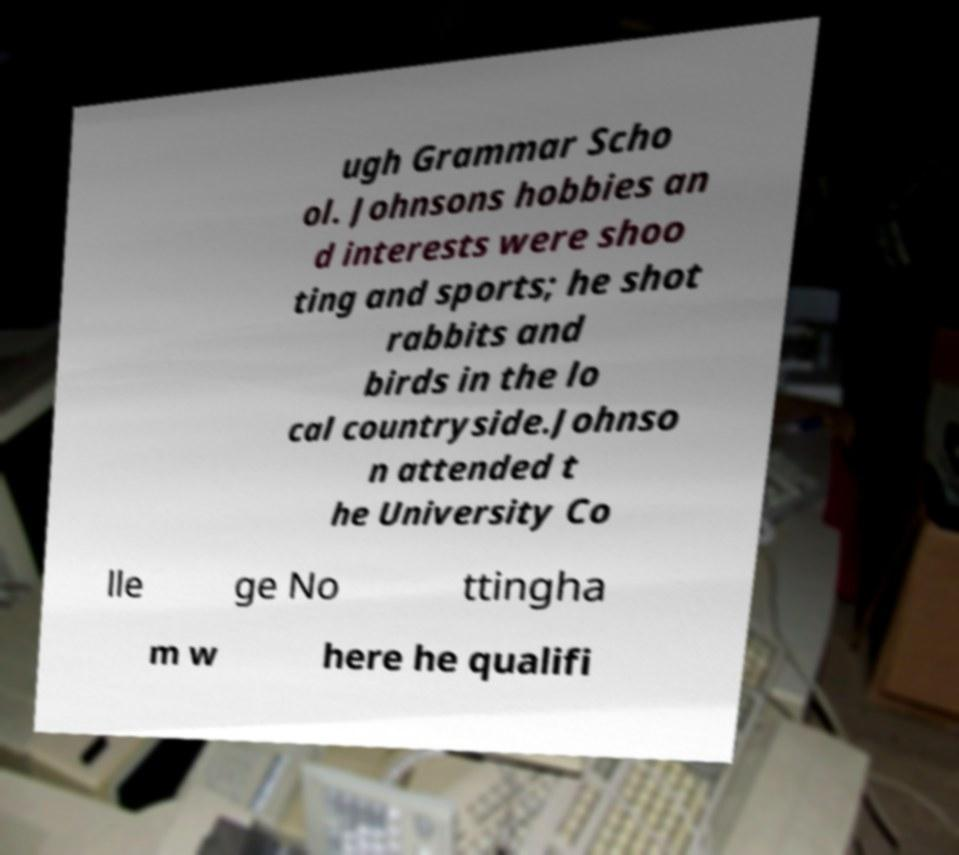Can you read and provide the text displayed in the image?This photo seems to have some interesting text. Can you extract and type it out for me? ugh Grammar Scho ol. Johnsons hobbies an d interests were shoo ting and sports; he shot rabbits and birds in the lo cal countryside.Johnso n attended t he University Co lle ge No ttingha m w here he qualifi 